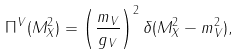Convert formula to latex. <formula><loc_0><loc_0><loc_500><loc_500>\Pi ^ { V } ( M _ { X } ^ { 2 } ) = \left ( \frac { m _ { V } } { g _ { V } } \right ) ^ { 2 } \delta ( M _ { X } ^ { 2 } - m _ { V } ^ { 2 } ) ,</formula> 